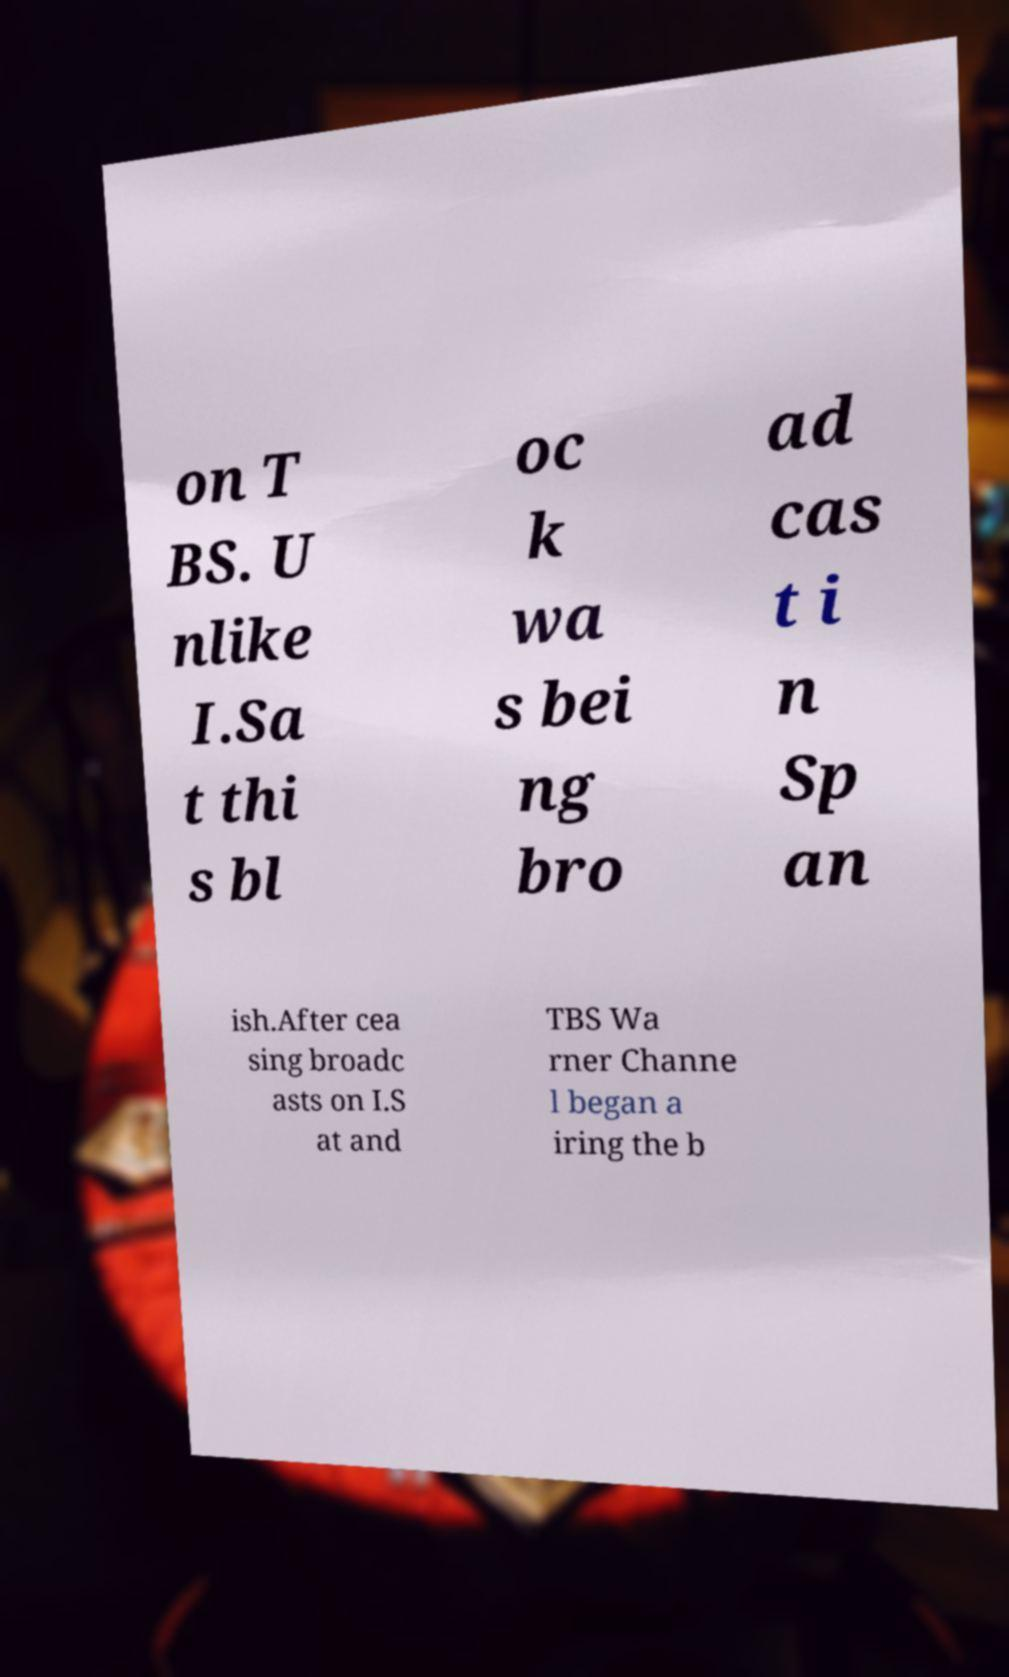Please identify and transcribe the text found in this image. on T BS. U nlike I.Sa t thi s bl oc k wa s bei ng bro ad cas t i n Sp an ish.After cea sing broadc asts on I.S at and TBS Wa rner Channe l began a iring the b 